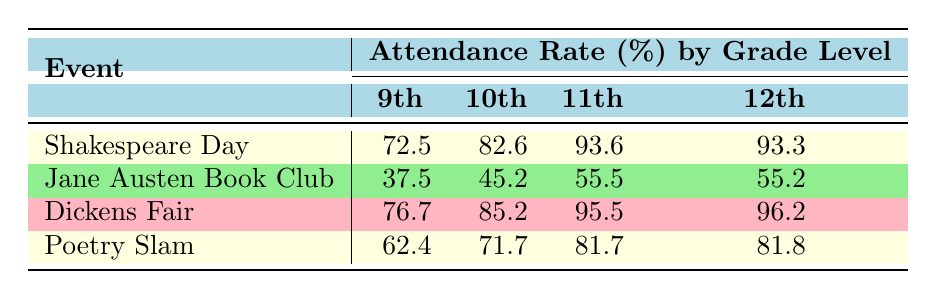What was the attendance rate for 11th graders on Shakespeare Day? The attendance rate can be found in the table under the row for Shakespeare Day and the column for 11th graders. It shows an attendance rate of 93.6%.
Answer: 93.6% Which event had the highest attendance rate among 12th graders? To find this, compare the attendance rates for 12th graders across all events in the 12th grade column. The highest rate is from the Dickens Fair at 96.2%.
Answer: Dickens Fair What was the average attendance rate for 9th graders across all events? Add the attendance rates for 9th graders from each event: (72.5 + 37.5 + 76.7 + 62.4) = 249.1. Then, divide by the number of events (4): 249.1 / 4 = 62.275.
Answer: 62.3 Did 10th graders have a higher attendance rate at the Poetry Slam compared to the Jane Austen Book Club? The table shows that the attendance rate for 10th graders at the Poetry Slam is 71.7%, while at the Jane Austen Book Club it is 45.2%. Since 71.7% is greater than 45.2%, the answer is yes.
Answer: Yes Which grade level showed the least participation in the Jane Austen Book Club? The table shows the number of participants for each grade under the Jane Austen Book Club event. The lowest number is for 9th graders with 18 participants.
Answer: 9th grade 